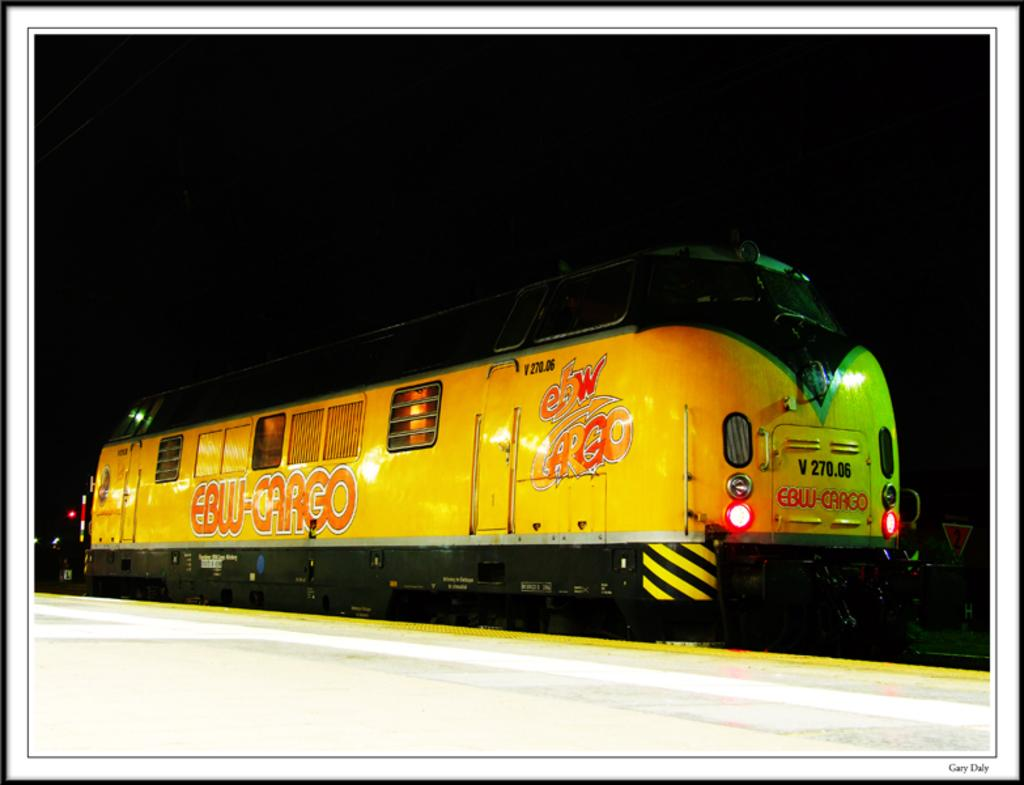What is the main subject of the image? The main subject of the image is a train. Where is the train located in the image? The train is on a railway track. What else can be seen in the image besides the train? There is a platform in the image. What is the color of the train? The train is yellow in color. What is the condition of the background in the image? The background of the image is dark. How many babies are visible on the train in the image? There are no babies visible on the train in the image. What direction is the wind blowing in the image? There is no indication of wind in the image. 